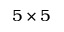Convert formula to latex. <formula><loc_0><loc_0><loc_500><loc_500>5 \times 5</formula> 